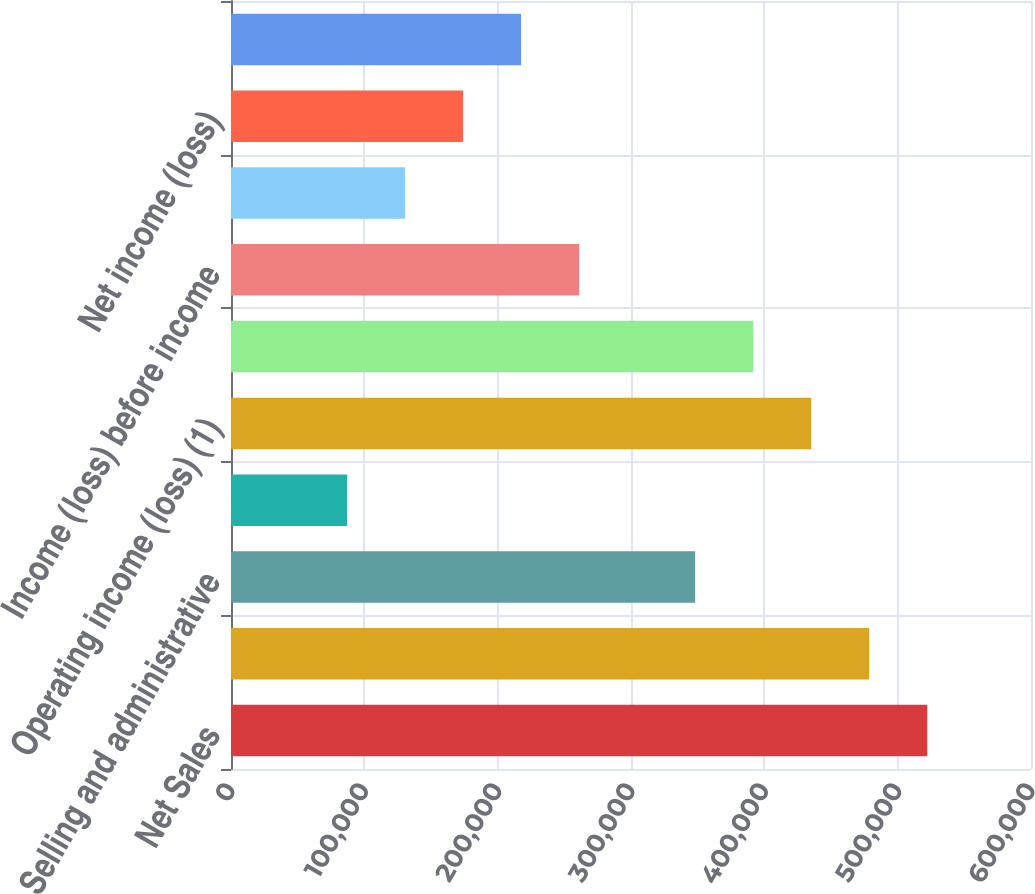<chart> <loc_0><loc_0><loc_500><loc_500><bar_chart><fcel>Net Sales<fcel>Gross profit (1)<fcel>Selling and administrative<fcel>Amortization of intangibles<fcel>Operating income (loss) (1)<fcel>Interest expense net<fcel>Income (loss) before income<fcel>Provision (benefit) for income<fcel>Net income (loss)<fcel>Net income (loss) available to<nl><fcel>522197<fcel>478680<fcel>348131<fcel>87033.2<fcel>435164<fcel>391648<fcel>261099<fcel>130550<fcel>174066<fcel>217582<nl></chart> 